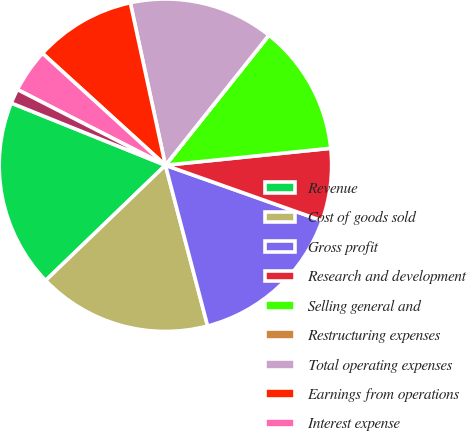Convert chart. <chart><loc_0><loc_0><loc_500><loc_500><pie_chart><fcel>Revenue<fcel>Cost of goods sold<fcel>Gross profit<fcel>Research and development<fcel>Selling general and<fcel>Restructuring expenses<fcel>Total operating expenses<fcel>Earnings from operations<fcel>Interest expense<fcel>Interest income<nl><fcel>18.3%<fcel>16.89%<fcel>15.49%<fcel>7.05%<fcel>12.67%<fcel>0.01%<fcel>14.08%<fcel>9.86%<fcel>4.23%<fcel>1.42%<nl></chart> 